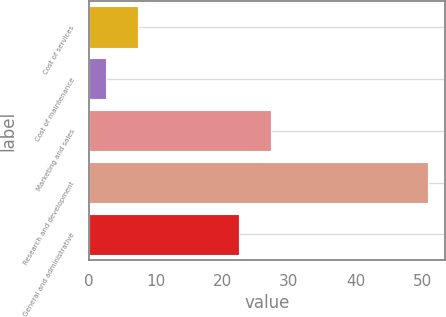<chart> <loc_0><loc_0><loc_500><loc_500><bar_chart><fcel>Cost of services<fcel>Cost of maintenance<fcel>Marketing and sales<fcel>Research and development<fcel>General and administrative<nl><fcel>7.34<fcel>2.5<fcel>27.34<fcel>50.9<fcel>22.5<nl></chart> 